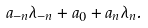Convert formula to latex. <formula><loc_0><loc_0><loc_500><loc_500>a _ { - n } \lambda _ { - n } + a _ { 0 } + a _ { n } \lambda _ { n } .</formula> 